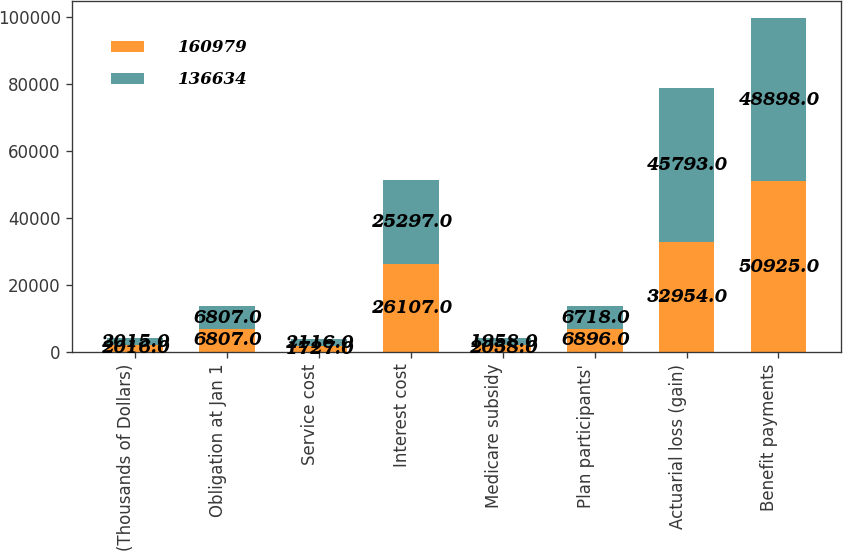Convert chart. <chart><loc_0><loc_0><loc_500><loc_500><stacked_bar_chart><ecel><fcel>(Thousands of Dollars)<fcel>Obligation at Jan 1<fcel>Service cost<fcel>Interest cost<fcel>Medicare subsidy<fcel>Plan participants'<fcel>Actuarial loss (gain)<fcel>Benefit payments<nl><fcel>160979<fcel>2016<fcel>6807<fcel>1727<fcel>26107<fcel>2058<fcel>6896<fcel>32954<fcel>50925<nl><fcel>136634<fcel>2015<fcel>6807<fcel>2116<fcel>25297<fcel>1958<fcel>6718<fcel>45793<fcel>48898<nl></chart> 